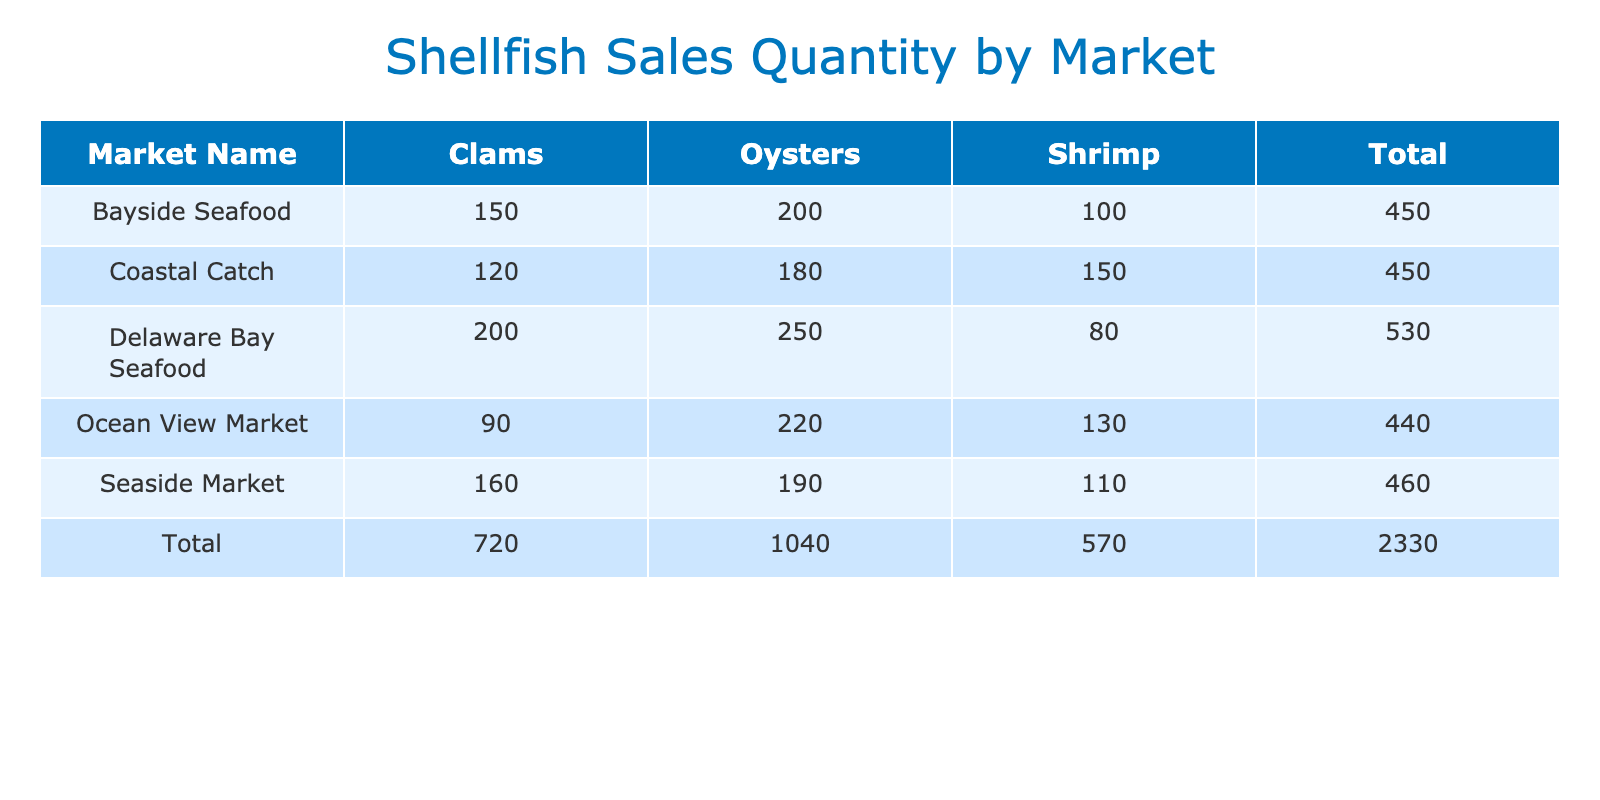What is the total sales quantity of Oysters across all markets? To find the total sales quantity of Oysters, we need to add up the sales quantities listed for Oysters from each market: 200 (Bayside Seafood) + 180 (Coastal Catch) + 250 (Delaware Bay Seafood) + 220 (Ocean View Market) + 190 (Seaside Market) = 1,040.
Answer: 1,040 Which market sold the highest quantity of Clams? By looking at the Clams sales quantities for each market, we find: Bayside Seafood (150), Coastal Catch (120), Delaware Bay Seafood (200), Ocean View Market (90), Seaside Market (160). The highest is 200 from Delaware Bay Seafood.
Answer: Delaware Bay Seafood What is the average sales value of Shrimp across all markets? To find the average sales value of Shrimp, first sum the values: 400 (Bayside Seafood) + 600 (Coastal Catch) + 320 (Delaware Bay Seafood) + 520 (Ocean View Market) + 440 (Seaside Market) = 2,280. There are 5 markets, so the average is 2,280 / 5 = 456.
Answer: 456 Did Coastal Catch sell more Oysters than Ocean View Market? Comparing the sales quantities for Oysters: Coastal Catch sold 180, while Ocean View Market sold 220. Since 180 is less than 220, the statement is false.
Answer: No What is the total sales value of all Clams sold in the Seaside Market? The sales value for Clams in Seaside Market is given directly as 320. Therefore, the total sales value of Clams sold there is simply 320.
Answer: 320 Which type of shellfish had the highest overall sales quantity? Summing the sales for each type of shellfish: Clams (150 + 120 + 200 + 90 + 160 = 820), Oysters (200 + 180 + 250 + 220 + 190 = 1,040), Shrimp (100 + 150 + 80 + 130 + 110 = 570). Oysters have the highest quantity at 1,040.
Answer: Oysters Which market had the lowest total sales quantity? Calculate total sales quantity for each market: Bayside Seafood (150 + 200 + 100 = 450), Coastal Catch (120 + 180 + 150 = 450), Delaware Bay Seafood (200 + 250 + 80 = 530), Ocean View Market (90 + 220 + 130 = 440), Seaside Market (160 + 190 + 110 = 460). Ocean View Market had the lowest total of 440.
Answer: Ocean View Market Is the total sales value of all shellfish sold in Bayside Seafood greater than 1,000? The total sales value for Bayside Seafood is 300 (Clams) + 600 (Oysters) + 400 (Shrimp) = 1,300. Since 1,300 is greater than 1,000, the answer is yes.
Answer: Yes What is the difference in sales quantity of Shrimp between the market with the highest sales and the market with the lowest sales? The highest Shrimp sales is 600 from Coastal Catch, and the lowest is 80 from Delaware Bay Seafood. The difference is 600 - 80 = 520.
Answer: 520 